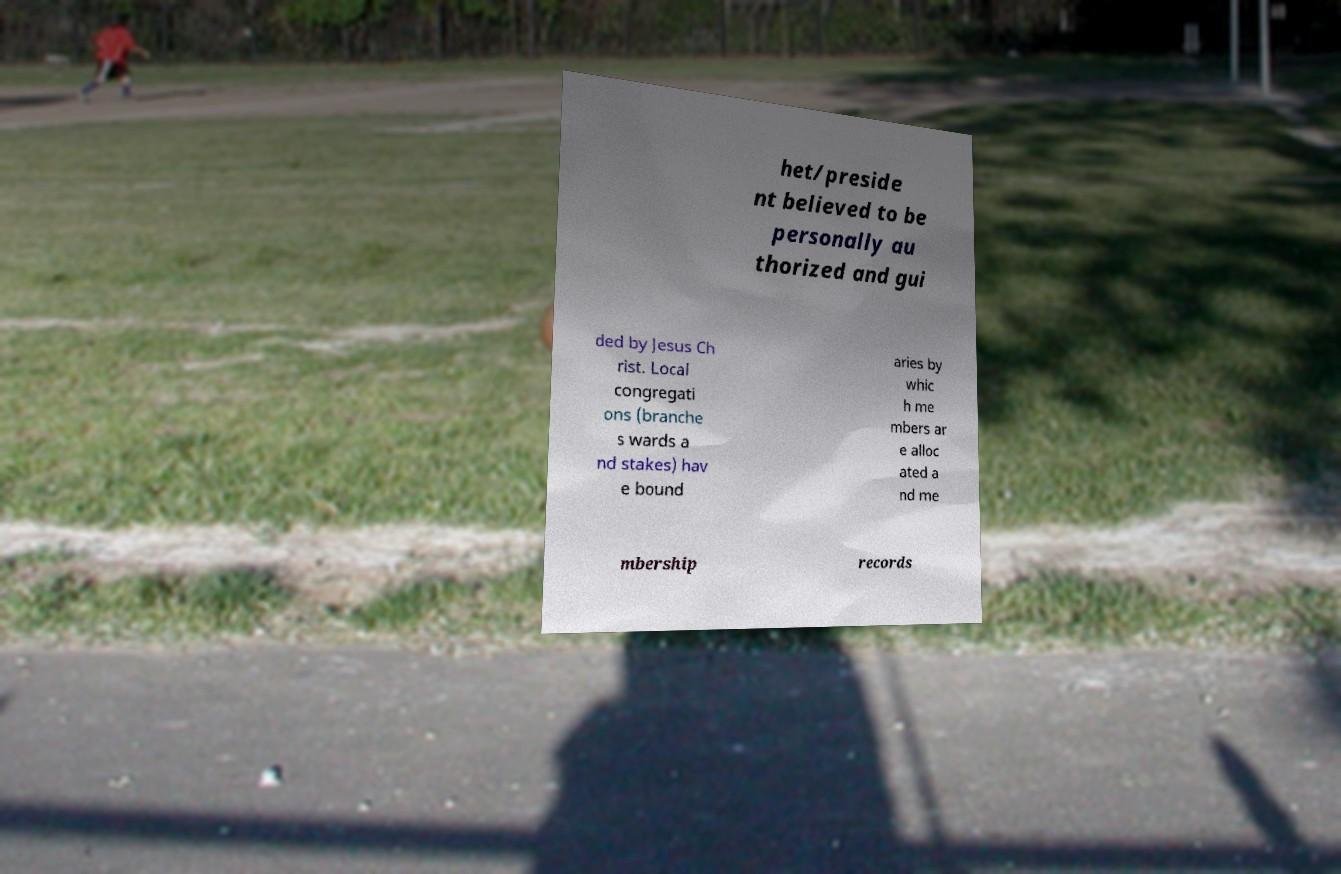Could you assist in decoding the text presented in this image and type it out clearly? het/preside nt believed to be personally au thorized and gui ded by Jesus Ch rist. Local congregati ons (branche s wards a nd stakes) hav e bound aries by whic h me mbers ar e alloc ated a nd me mbership records 